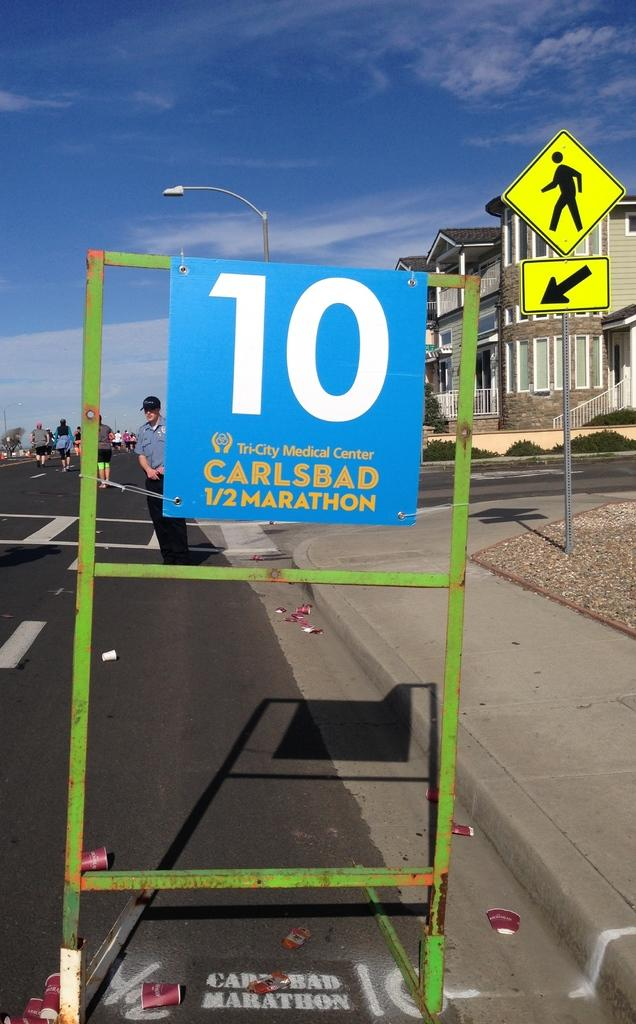Provide a one-sentence caption for the provided image. A blue sign for the Carlsbad 1/2 Marathon displays the number 10 in white text. 